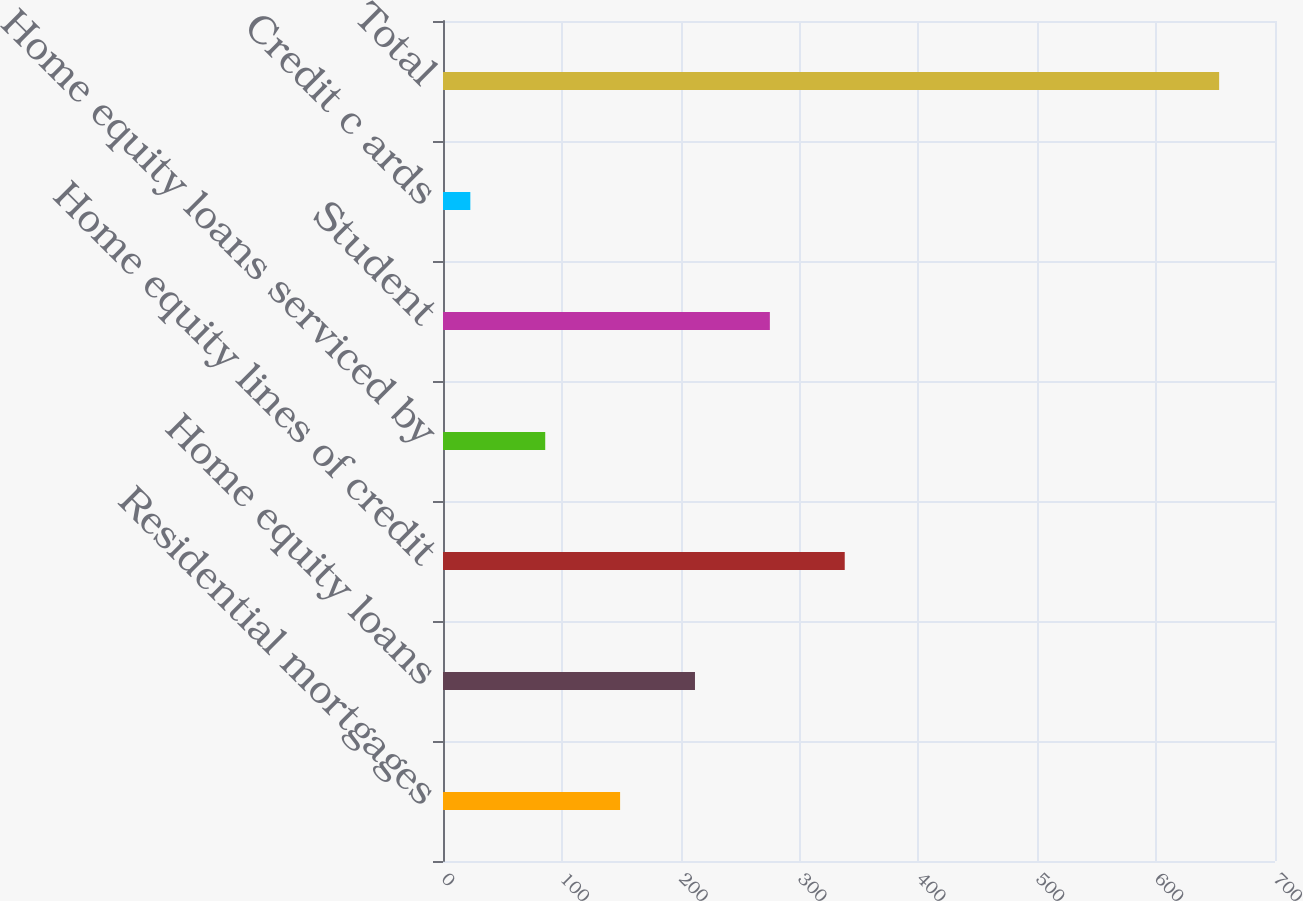Convert chart. <chart><loc_0><loc_0><loc_500><loc_500><bar_chart><fcel>Residential mortgages<fcel>Home equity loans<fcel>Home equity lines of credit<fcel>Home equity loans serviced by<fcel>Student<fcel>Credit c ards<fcel>Total<nl><fcel>149<fcel>212<fcel>338<fcel>86<fcel>275<fcel>23<fcel>653<nl></chart> 